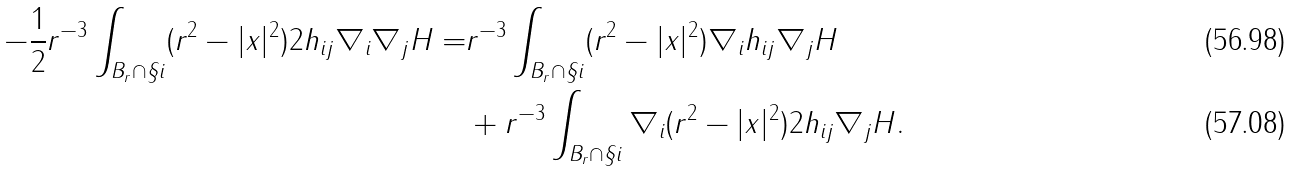<formula> <loc_0><loc_0><loc_500><loc_500>- \frac { 1 } { 2 } r ^ { - 3 } \int _ { B _ { r } \cap \S i } ( r ^ { 2 } - | x | ^ { 2 } ) 2 h _ { i j } \nabla _ { i } \nabla _ { j } H = & r ^ { - 3 } \int _ { B _ { r } \cap \S i } ( r ^ { 2 } - | x | ^ { 2 } ) \nabla _ { i } h _ { i j } \nabla _ { j } H \\ & + r ^ { - 3 } \int _ { B _ { r } \cap \S i } \nabla _ { i } ( r ^ { 2 } - | x | ^ { 2 } ) 2 h _ { i j } \nabla _ { j } H .</formula> 